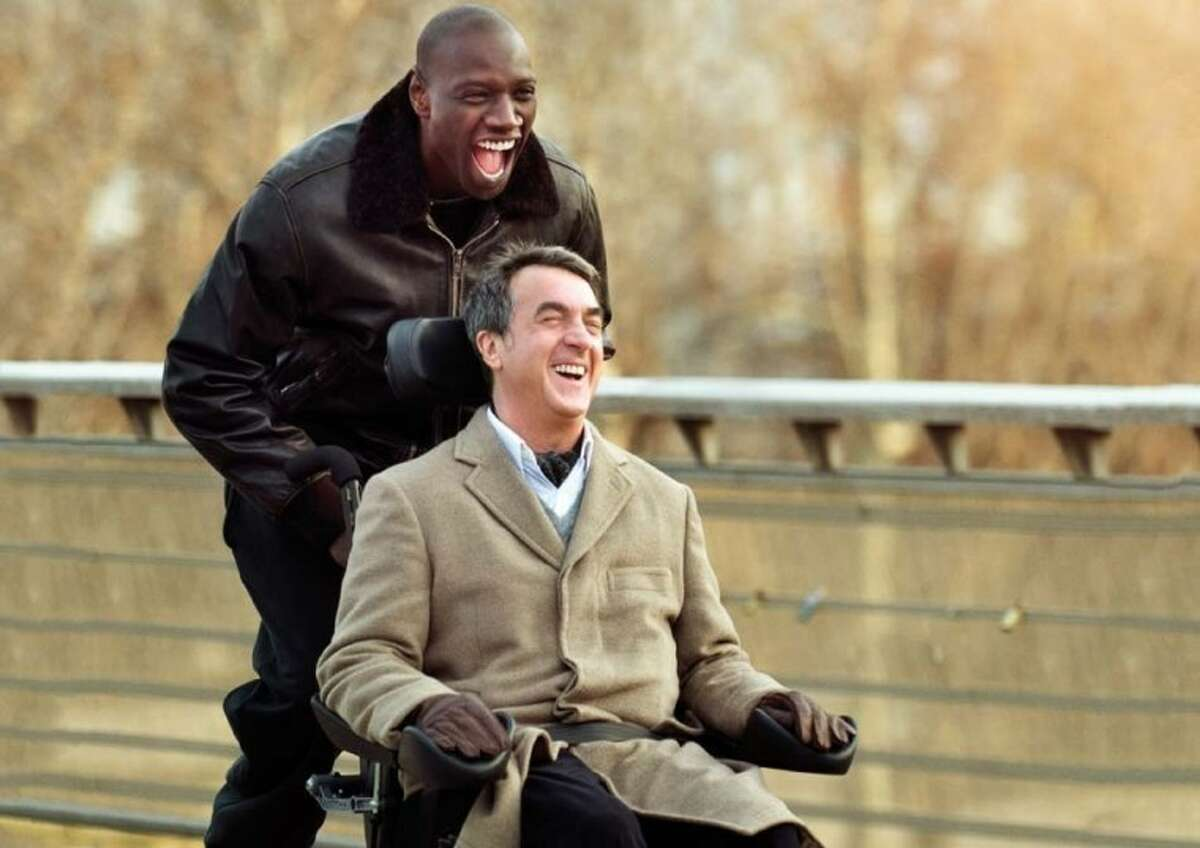What is the significance of the location in this image? The bridge in this image symbolizes connection and transition, themes central to 'The Intouchables.' It represents the bridging of different worlds and experiences, as seen in the friendship between the two main characters from vastly different backgrounds. The serene setting also enhances the mood of freedom and joy, emphasizing the liberation felt by both characters in each other's company. 